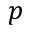<formula> <loc_0><loc_0><loc_500><loc_500>p</formula> 